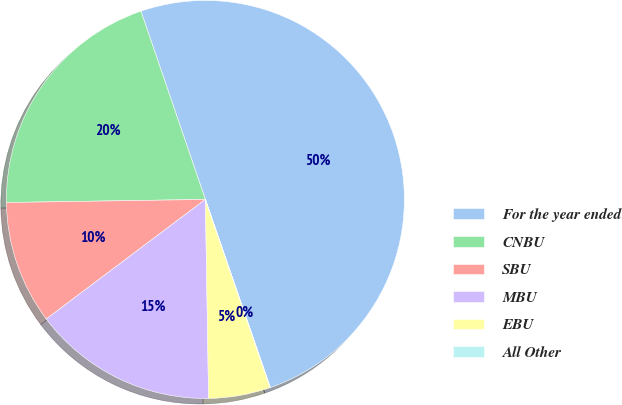Convert chart. <chart><loc_0><loc_0><loc_500><loc_500><pie_chart><fcel>For the year ended<fcel>CNBU<fcel>SBU<fcel>MBU<fcel>EBU<fcel>All Other<nl><fcel>49.95%<fcel>20.0%<fcel>10.01%<fcel>15.0%<fcel>5.02%<fcel>0.02%<nl></chart> 